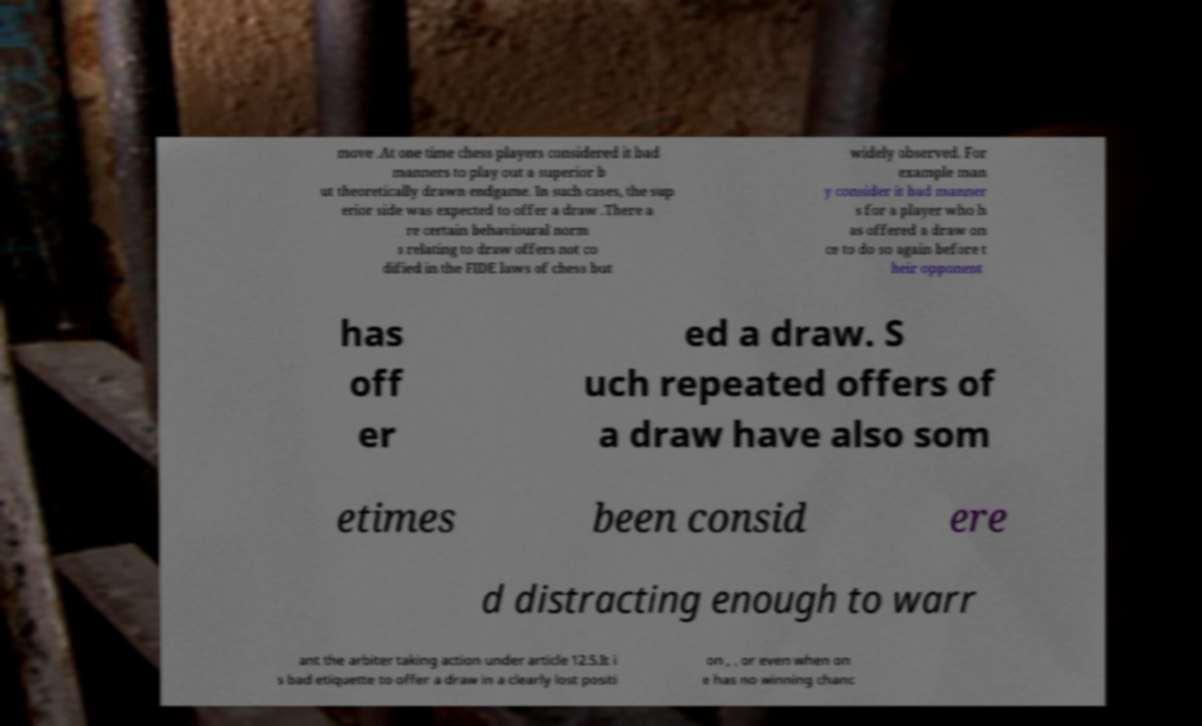Could you assist in decoding the text presented in this image and type it out clearly? move .At one time chess players considered it bad manners to play out a superior b ut theoretically drawn endgame. In such cases, the sup erior side was expected to offer a draw .There a re certain behavioural norm s relating to draw offers not co dified in the FIDE laws of chess but widely observed. For example man y consider it bad manner s for a player who h as offered a draw on ce to do so again before t heir opponent has off er ed a draw. S uch repeated offers of a draw have also som etimes been consid ere d distracting enough to warr ant the arbiter taking action under article 12.5.It i s bad etiquette to offer a draw in a clearly lost positi on , , or even when on e has no winning chanc 